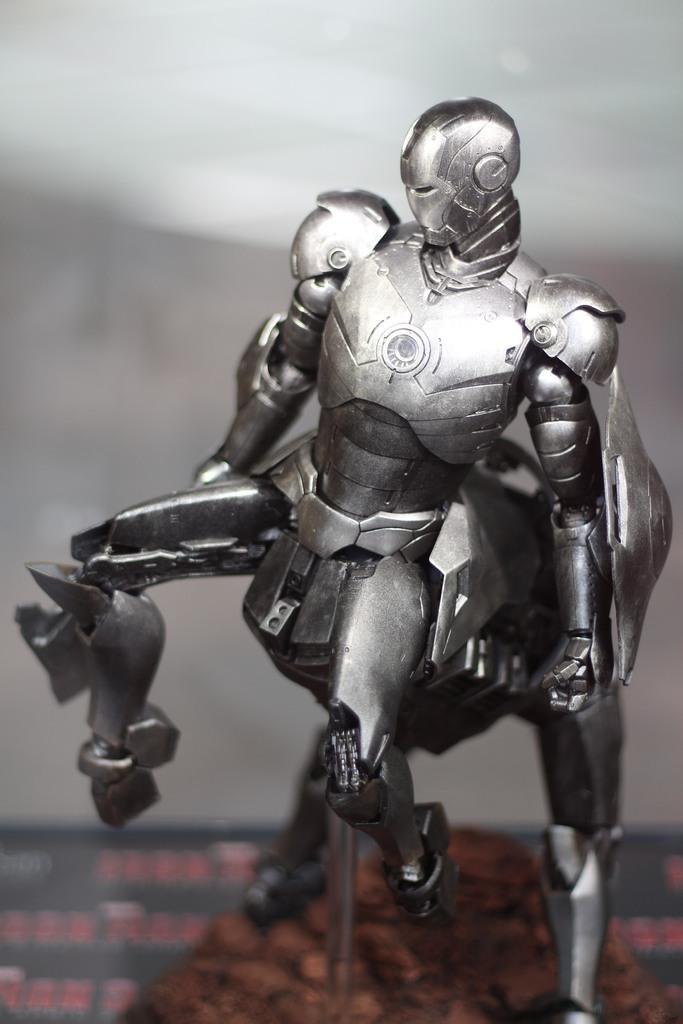In one or two sentences, can you explain what this image depicts? In this image we can see toy robots. At the bottom there is a surface. 